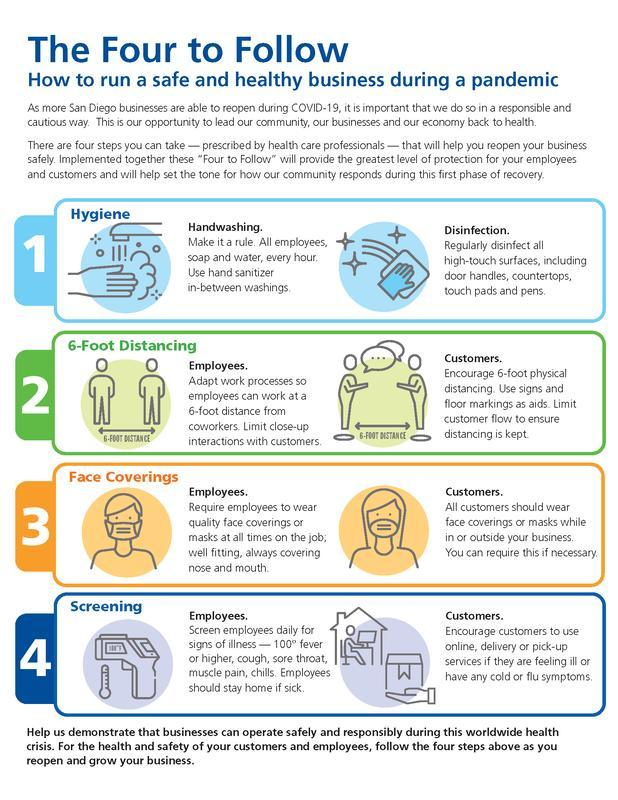What are the different types of aids?
Answer the question with a short phrase. signs, floor markings What is the quality of a mask mentioned in this infographic? well fitting 